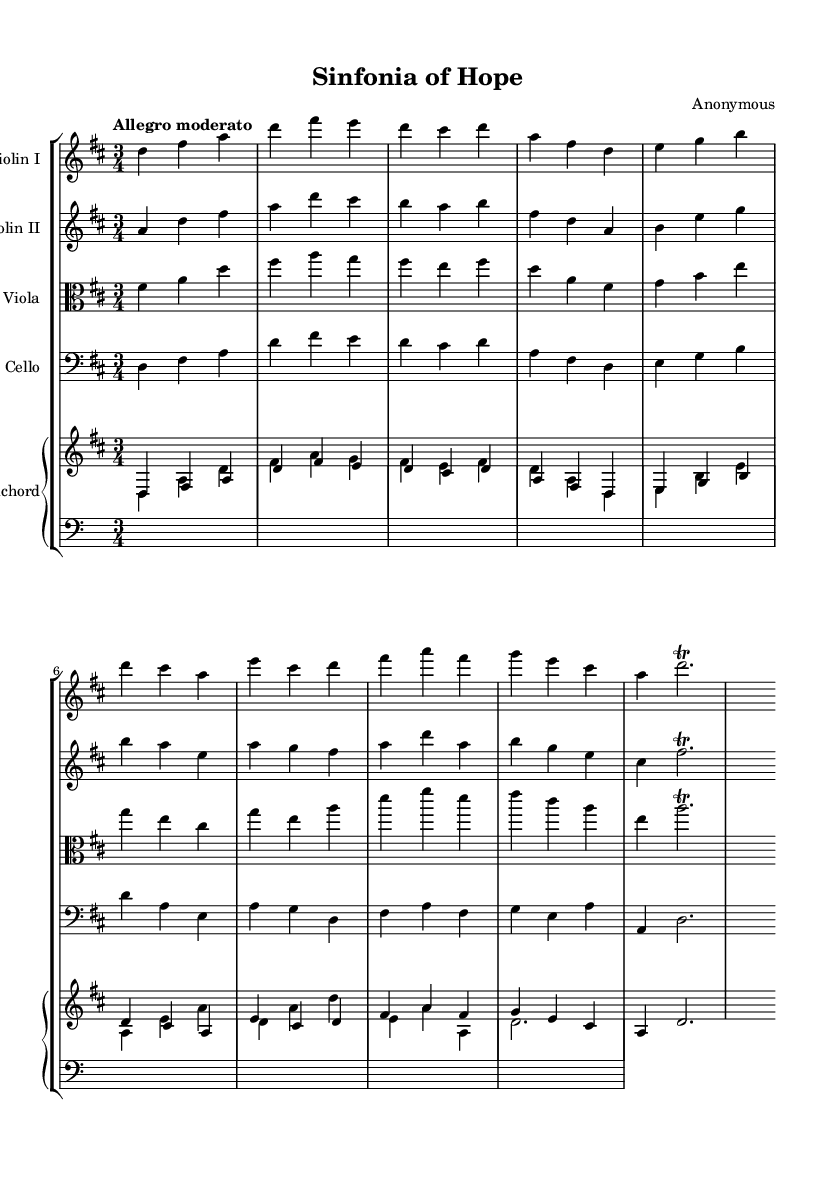What is the key signature of this music? The key signature is D major, which has two sharps (F# and C#). You can find the key signature at the beginning of the score just after the clef symbol.
Answer: D major What is the time signature of this music? The time signature is 3/4, which indicates three beats per measure with a quarter note receiving one beat. This is typically shown as two numbers at the beginning of the score in the same area as the key signature.
Answer: 3/4 What is the tempo marking of this piece? The tempo marking is "Allegro moderato," which denotes a moderate quick tempo. Tempo markings are usually placed above the staff near the start of the piece.
Answer: Allegro moderato How many instruments are there in this piece? There are five instruments: two violins, one viola, one cello, and one harpsichord. This can typically be determined by counting the distinct staffs on the score, as each staff represents a different instrument.
Answer: Five What is the ornament used in the last note of the first violin part? The ornament used is a trill, indicated by the symbol "tr" written above the note in the score. This ornamentation is common in Baroque music for embellishing the melody.
Answer: Trill Which instrument plays the lowest pitch in this piece? The instrument that plays the lowest pitch is the cello, which is indicated by being notated on the bass clef. You can identify this by looking at the clef and the notes it plays, which are typically in the lower range of the staff.
Answer: Cello What does the term "Sinfonia" refer to in this context? The term "Sinfonia" refers to a type of orchestral piece commonly found in Baroque music, typically serving as an introduction or overture. This is often indicated in the title header of the score.
Answer: Orchestral piece 